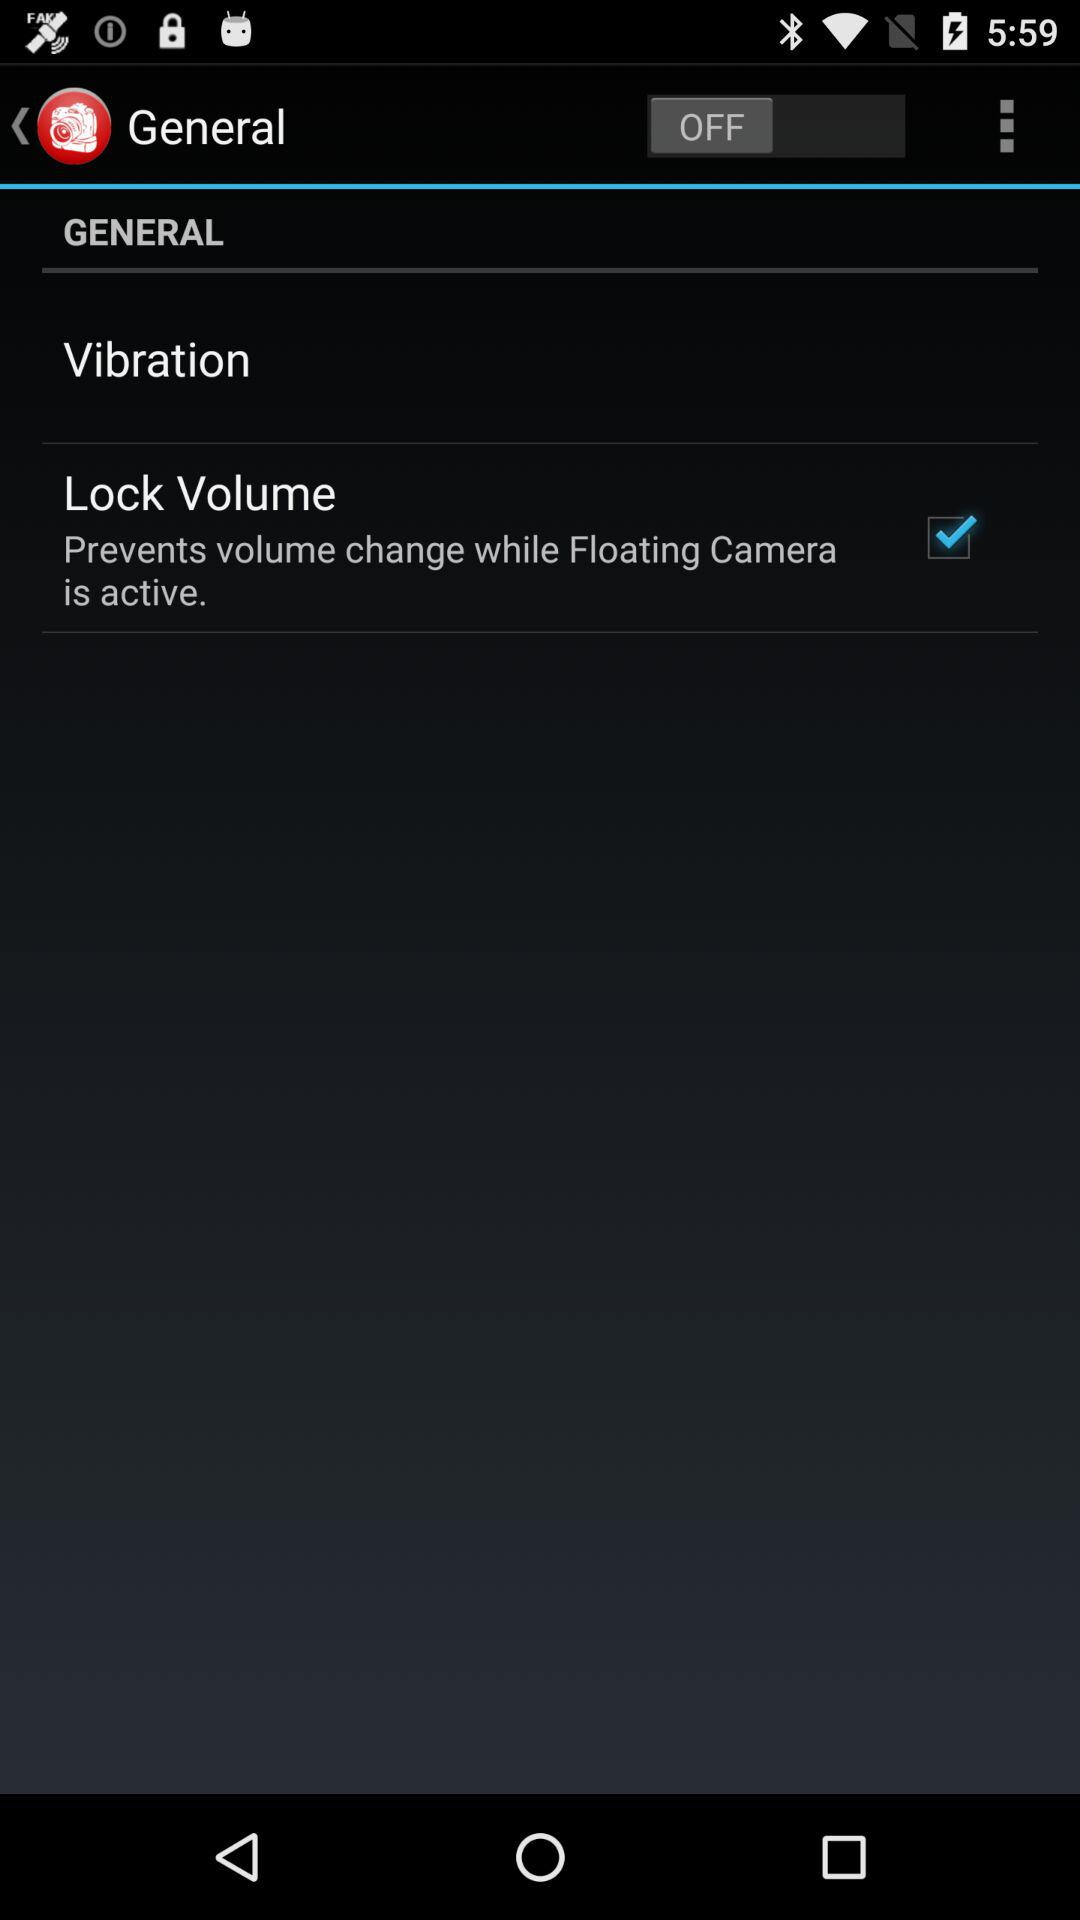What is the status of the "General"? The status is "off". 